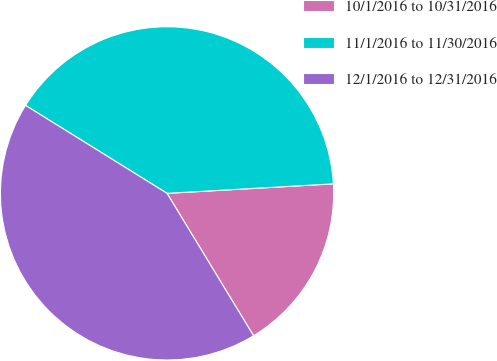<chart> <loc_0><loc_0><loc_500><loc_500><pie_chart><fcel>10/1/2016 to 10/31/2016<fcel>11/1/2016 to 11/30/2016<fcel>12/1/2016 to 12/31/2016<nl><fcel>17.22%<fcel>40.24%<fcel>42.54%<nl></chart> 